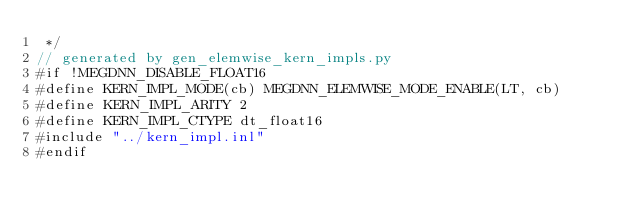<code> <loc_0><loc_0><loc_500><loc_500><_Cuda_> */
// generated by gen_elemwise_kern_impls.py
#if !MEGDNN_DISABLE_FLOAT16
#define KERN_IMPL_MODE(cb) MEGDNN_ELEMWISE_MODE_ENABLE(LT, cb)
#define KERN_IMPL_ARITY 2
#define KERN_IMPL_CTYPE dt_float16
#include "../kern_impl.inl"
#endif
</code> 